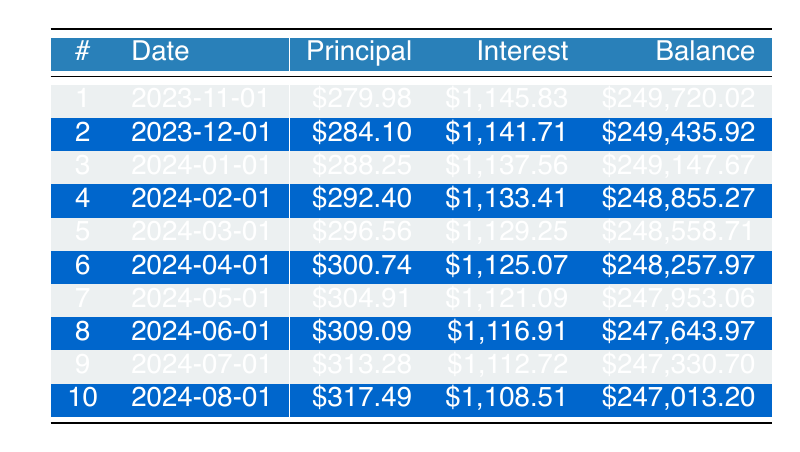What is the principal payment for the first installment? The table shows that the principal payment for the first installment, which corresponds to payment number 1, is listed in the "Principal" column for the date 2023-11-01 as 279.98.
Answer: 279.98 What is the total interest paid in the first three months? To find the total interest paid in the first three months, add the interest payments for each of the first three payments: 1145.83 + 1141.71 + 1137.56 = 3425.10.
Answer: 3425.10 Is the remaining balance after the second payment less than 249400? The remaining balance after the second payment, as stated in the table for payment number 2, is 249435.92, which is indeed greater than 249400. Therefore, the statement is false.
Answer: No What is the average principal payment for the first five months? To calculate the average principal payment for the first five months, sum the principal payments for those months: 279.98 + 284.10 + 288.25 + 292.40 + 296.56 = 1441.29. Then, divide by 5 (the number of months): 1441.29 / 5 = 288.258.
Answer: 288.26 What is the remaining balance after the fourth payment? The table indicates that the remaining balance after the fourth payment, on the date 2024-02-01, is 248855.27.
Answer: 248855.27 What is the difference between the interest payment in the first month and the interest payment in the tenth month? The interest payment for the first month is 1145.83, and for the tenth month, it is 1108.51. The difference is calculated as 1145.83 - 1108.51 = 37.32.
Answer: 37.32 What is the total amount paid over the first six months? To find the total amount paid over the first six months, multiply the monthly payment by 6: 2653.98 * 6 = 15923.88.
Answer: 15923.88 Is the principal payment for the seventh month higher than that for the third month? The principal payment for the seventh month is 304.91, while for the third month, it is 288.25. Since 304.91 is greater than 288.25, the statement is true.
Answer: Yes What is the difference between the total principal payments in the first eight months and the total interest payments in those months? First, sum the principal payments for the first eight months: (279.98 + 284.10 + 288.25 + 292.40 + 296.56 + 300.74 + 304.91 + 309.09) = 2,055.03. Then sum the interest payments for those months: (1145.83 + 1141.71 + 1137.56 + 1133.41 + 1129.25 + 1125.07 + 1121.09 + 1116.91) = 8,813.83. Finally, calculate the difference: 2055.03 - 8813.83 = -6,758.80.
Answer: -6758.80 